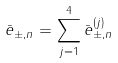<formula> <loc_0><loc_0><loc_500><loc_500>\bar { e } _ { \pm , n } = \sum _ { j = 1 } ^ { 4 } \bar { e } _ { \pm , n } ^ { ( j ) }</formula> 